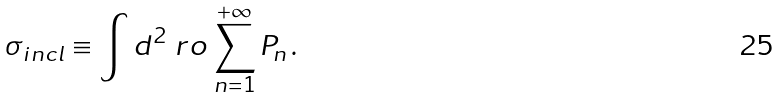Convert formula to latex. <formula><loc_0><loc_0><loc_500><loc_500>\sigma _ { i n c l } \equiv \int d ^ { 2 } { \ r o } \, \sum _ { n = 1 } ^ { + \infty } P _ { n } \, .</formula> 